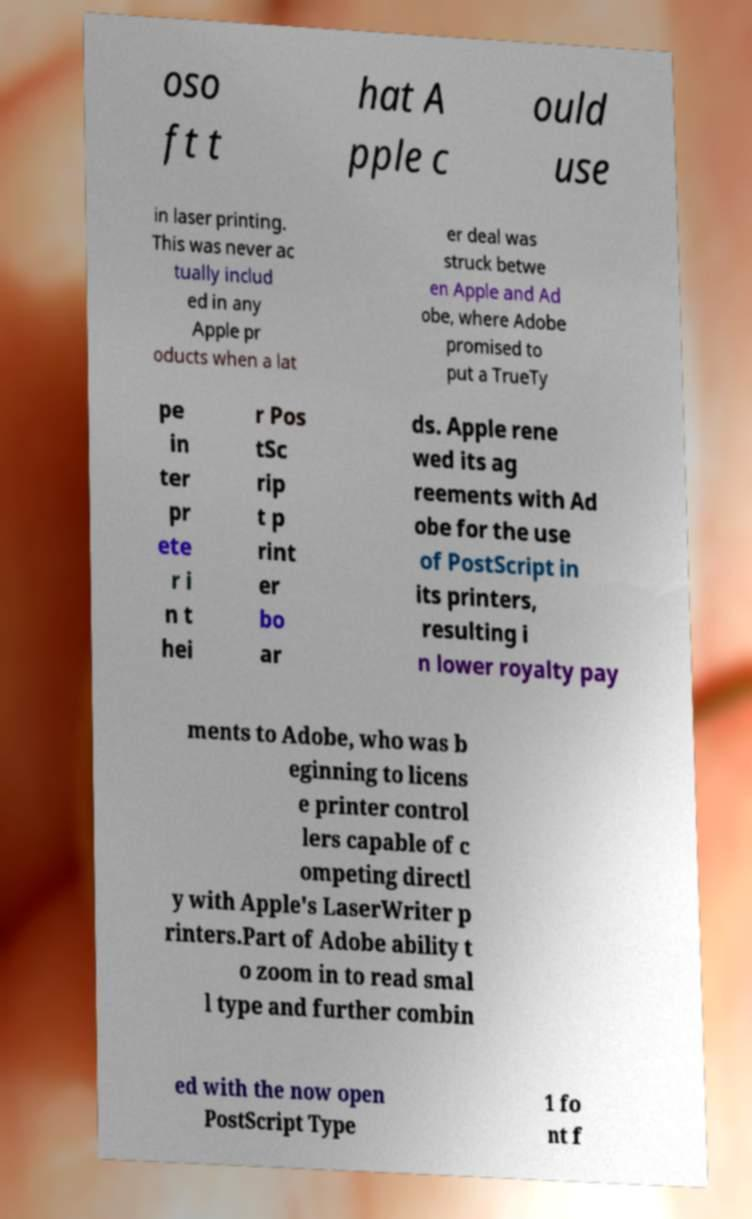Could you assist in decoding the text presented in this image and type it out clearly? oso ft t hat A pple c ould use in laser printing. This was never ac tually includ ed in any Apple pr oducts when a lat er deal was struck betwe en Apple and Ad obe, where Adobe promised to put a TrueTy pe in ter pr ete r i n t hei r Pos tSc rip t p rint er bo ar ds. Apple rene wed its ag reements with Ad obe for the use of PostScript in its printers, resulting i n lower royalty pay ments to Adobe, who was b eginning to licens e printer control lers capable of c ompeting directl y with Apple's LaserWriter p rinters.Part of Adobe ability t o zoom in to read smal l type and further combin ed with the now open PostScript Type 1 fo nt f 